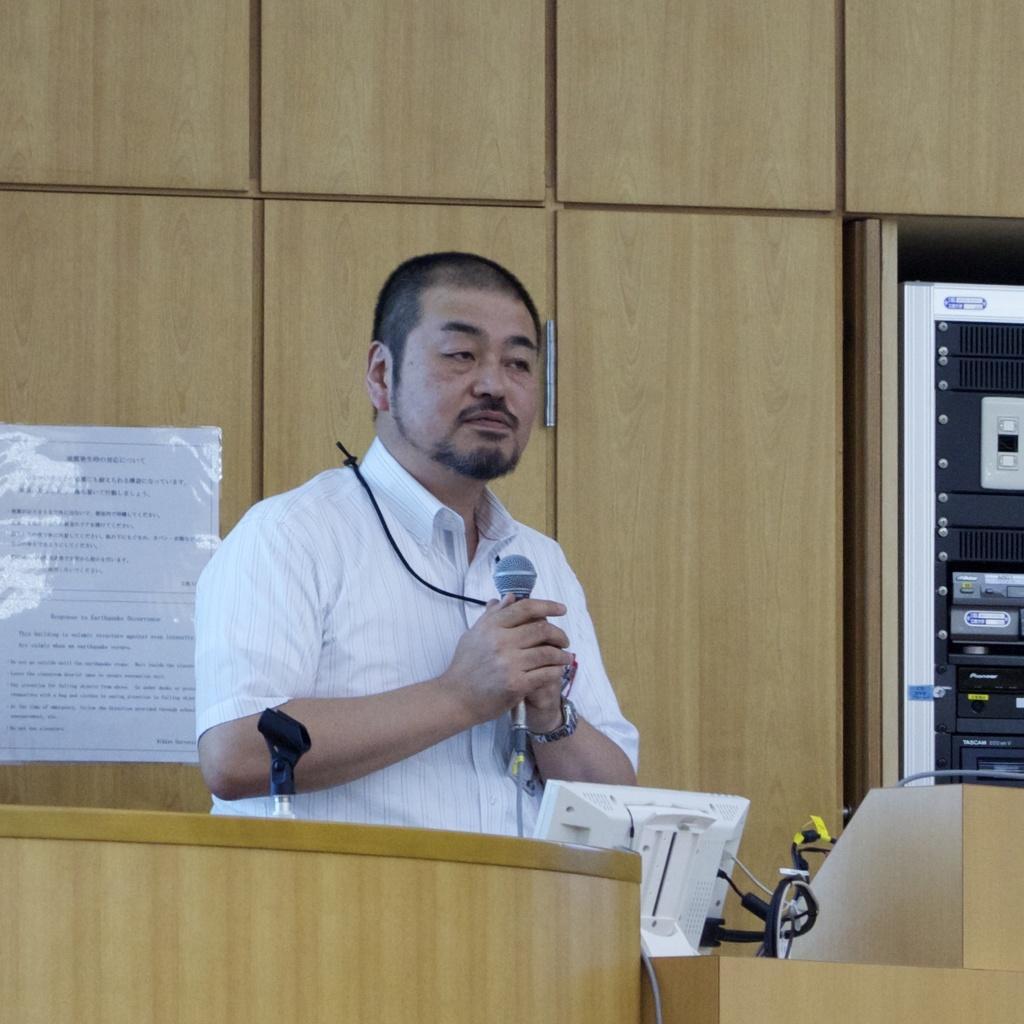In one or two sentences, can you explain what this image depicts? In this image we can see a person holding a microphone in his hand is standing in front of a podium. In the foreground we can see a screen. In the background, we can see group of electrical devices and a poster with some text. 